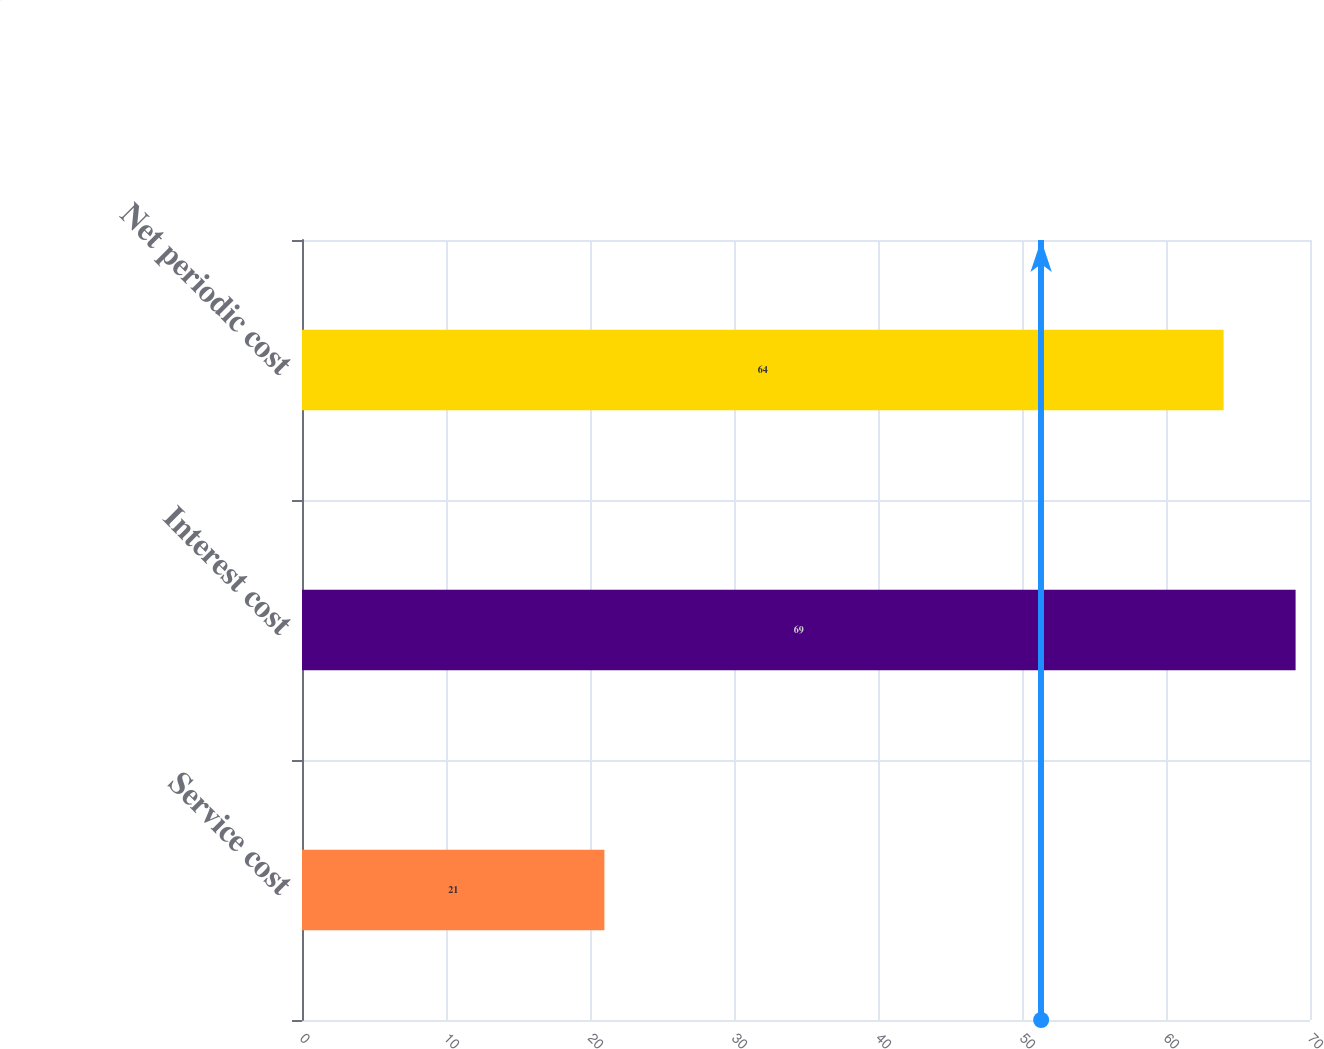Convert chart. <chart><loc_0><loc_0><loc_500><loc_500><bar_chart><fcel>Service cost<fcel>Interest cost<fcel>Net periodic cost<nl><fcel>21<fcel>69<fcel>64<nl></chart> 